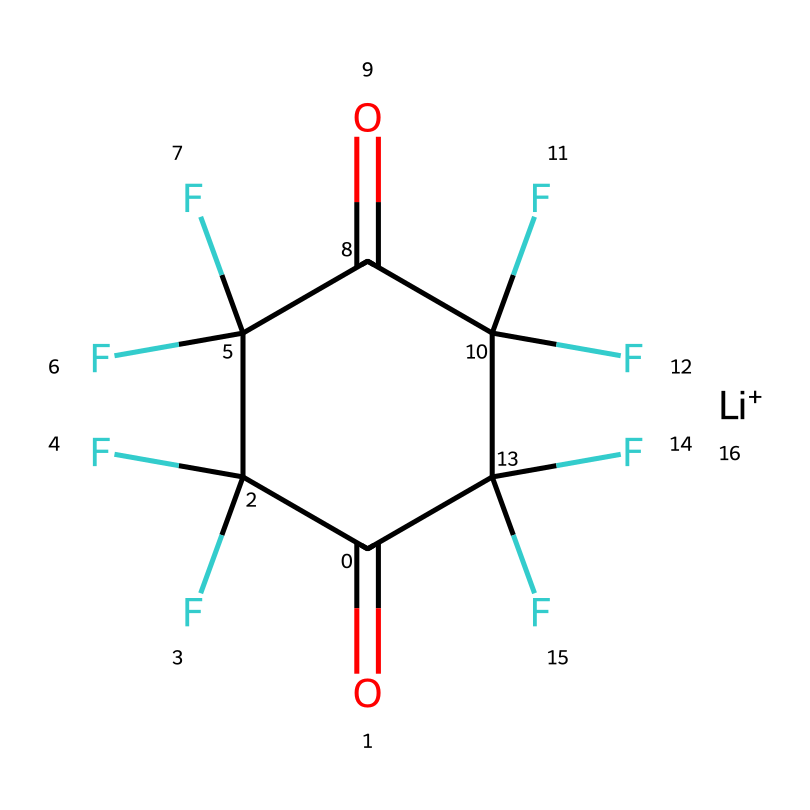What is the molecular formula of this compound? To determine the molecular formula, count the number of each type of atom present in the SMILES: there are 6 carbon (C) atoms, 10 fluorine (F) atoms, 2 oxygen (O) atoms, and 1 lithium (Li) atom. Therefore, the molecular formula is C6F10LiO2.
Answer: C6F10LiO2 How many carbon atoms are in the structure? By examining the SMILES representation, we can see that there are six "C" characters present, indicating there are six carbon atoms in the molecule.
Answer: 6 What functional group is present in this compound? The presence of the carbonyl group (C=O) indicates that this compound contains ketone functional groups, as the compound is structured with carbonyls between carbons, confirming it is a ketone.
Answer: ketone How many total fluorine atoms are attached to the structure? The SMILES representation has ten "F" characters, showing that there are ten fluorine atoms attached to the compound, contributing to the overall composition and properties of the compound.
Answer: 10 Is this compound ionic or covalent? The presence of lithium (Li+) suggests that it forms an ionic bond, while the rest of the structure, which consists of covalent bonds between carbon, fluorine, and oxygen, indicates that it is primarily a covalent compound with ionic characteristics due to lithium.
Answer: ionic What is the main characteristic of ketones that can be inferred from this structure? Ketones are characterized by the presence of the carbonyl group, which in this case appears twice in the structure, confirming the compound's classification as a ketone and highlighting its role in reactivity and properties.
Answer: carbonyl group 